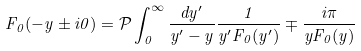<formula> <loc_0><loc_0><loc_500><loc_500>F _ { 0 } ( - y \pm i 0 ) = { \mathcal { P } } \int _ { 0 } ^ { \infty } \frac { d y ^ { \prime } } { y ^ { \prime } - y } \frac { 1 } { y ^ { \prime } F _ { 0 } ( y ^ { \prime } ) } \mp \frac { i \pi } { y F _ { 0 } ( y ) }</formula> 